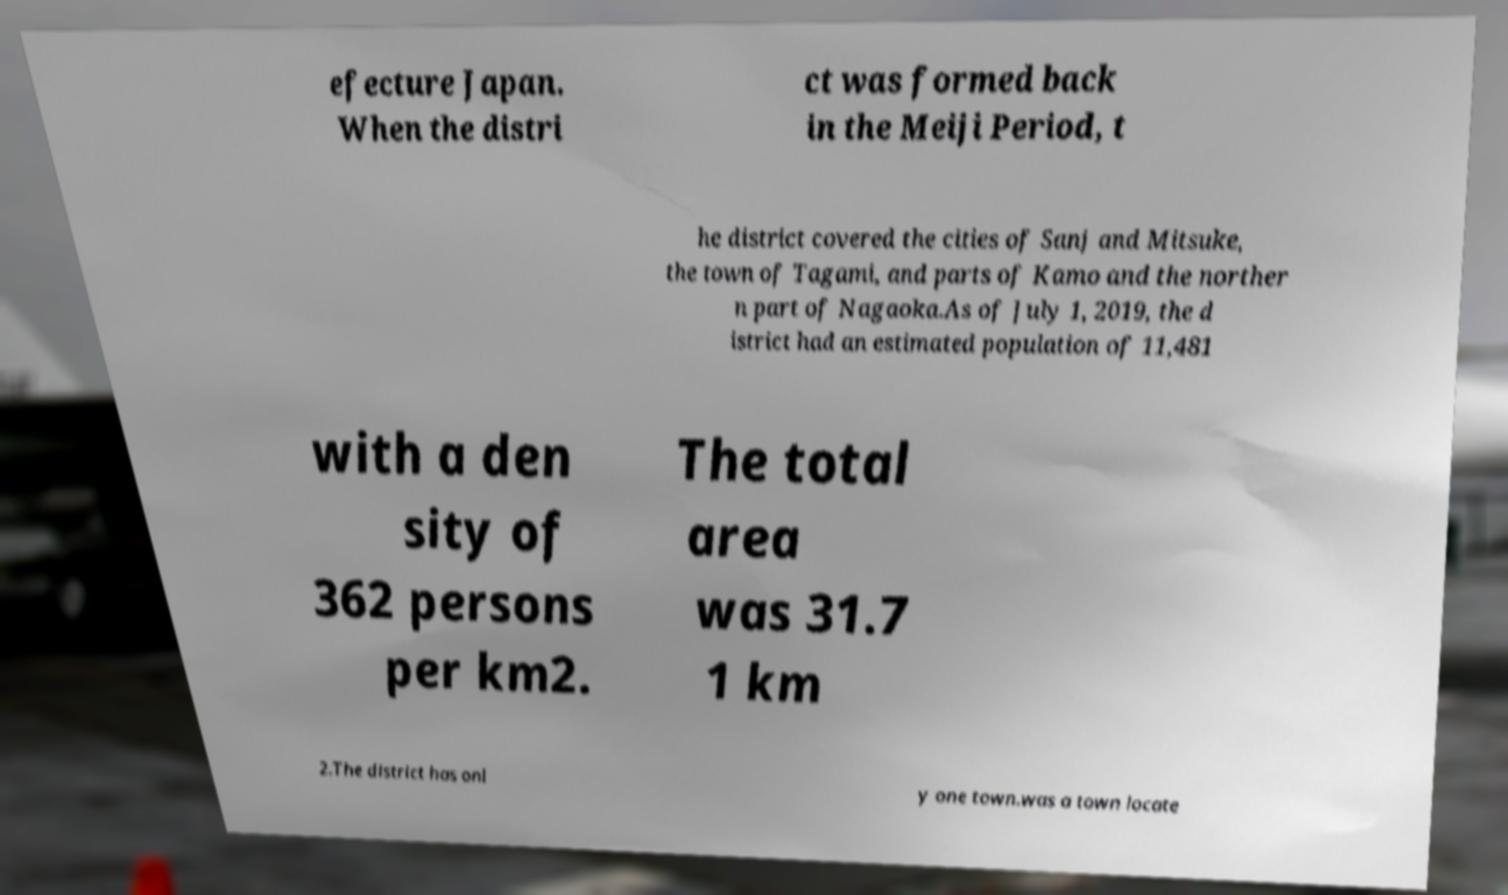I need the written content from this picture converted into text. Can you do that? efecture Japan. When the distri ct was formed back in the Meiji Period, t he district covered the cities of Sanj and Mitsuke, the town of Tagami, and parts of Kamo and the norther n part of Nagaoka.As of July 1, 2019, the d istrict had an estimated population of 11,481 with a den sity of 362 persons per km2. The total area was 31.7 1 km 2.The district has onl y one town.was a town locate 